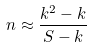<formula> <loc_0><loc_0><loc_500><loc_500>n \approx \frac { k ^ { 2 } - k } { S - k }</formula> 